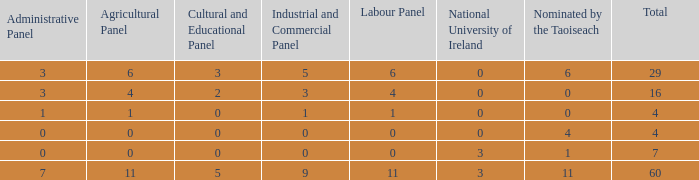What is the total number of agriculatural panels of the composition with more than 3 National Universities of Ireland? 0.0. 